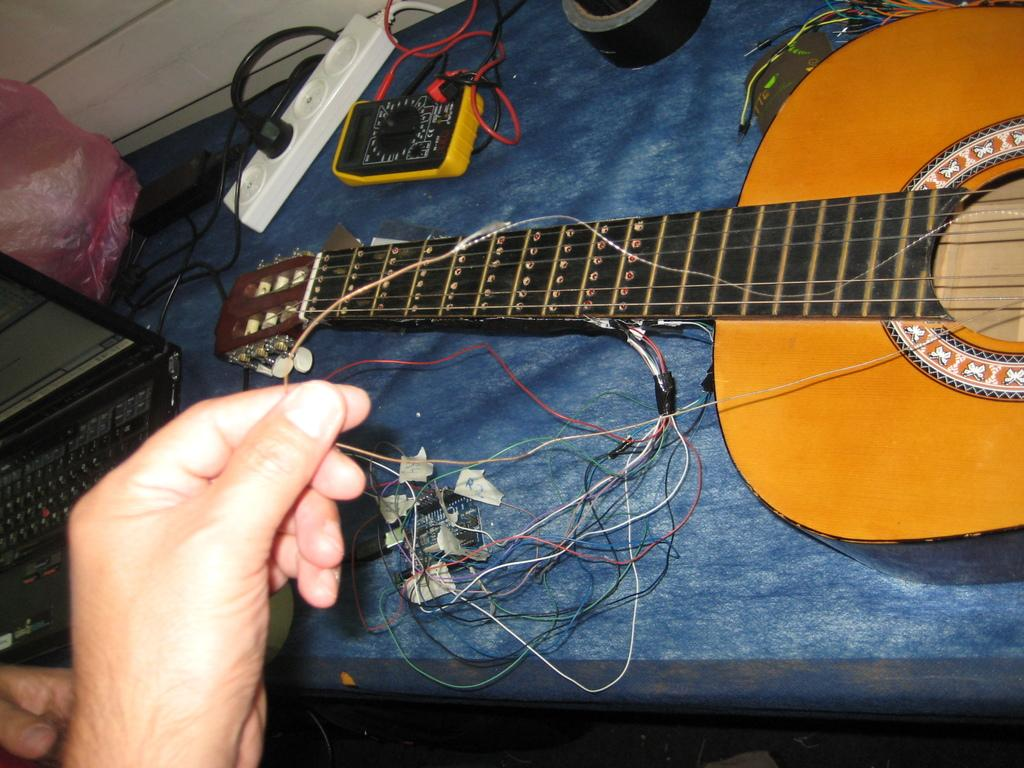What musical instrument is on the table in the image? There is a guitar on the table in the image. What is the man doing with the guitar? The man is holding the strings of the guitar. What electrical device is on the table? There is an extension box on the table. What electronic device is on the table? There is a laptop on the table. Is the man driving a car while holding the guitar strings in the image? No, the man is not driving a car in the image; he is holding the guitar strings while standing near a table. What type of paper is visible on the table in the image? There is no paper visible on the table in the image. 